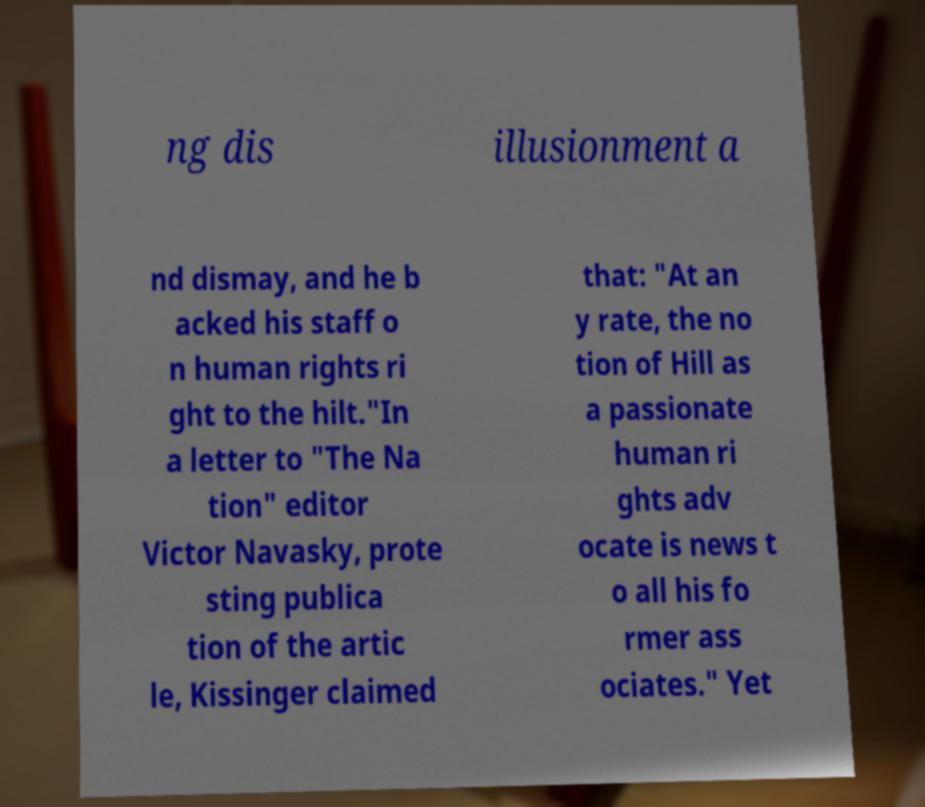I need the written content from this picture converted into text. Can you do that? ng dis illusionment a nd dismay, and he b acked his staff o n human rights ri ght to the hilt."In a letter to "The Na tion" editor Victor Navasky, prote sting publica tion of the artic le, Kissinger claimed that: "At an y rate, the no tion of Hill as a passionate human ri ghts adv ocate is news t o all his fo rmer ass ociates." Yet 